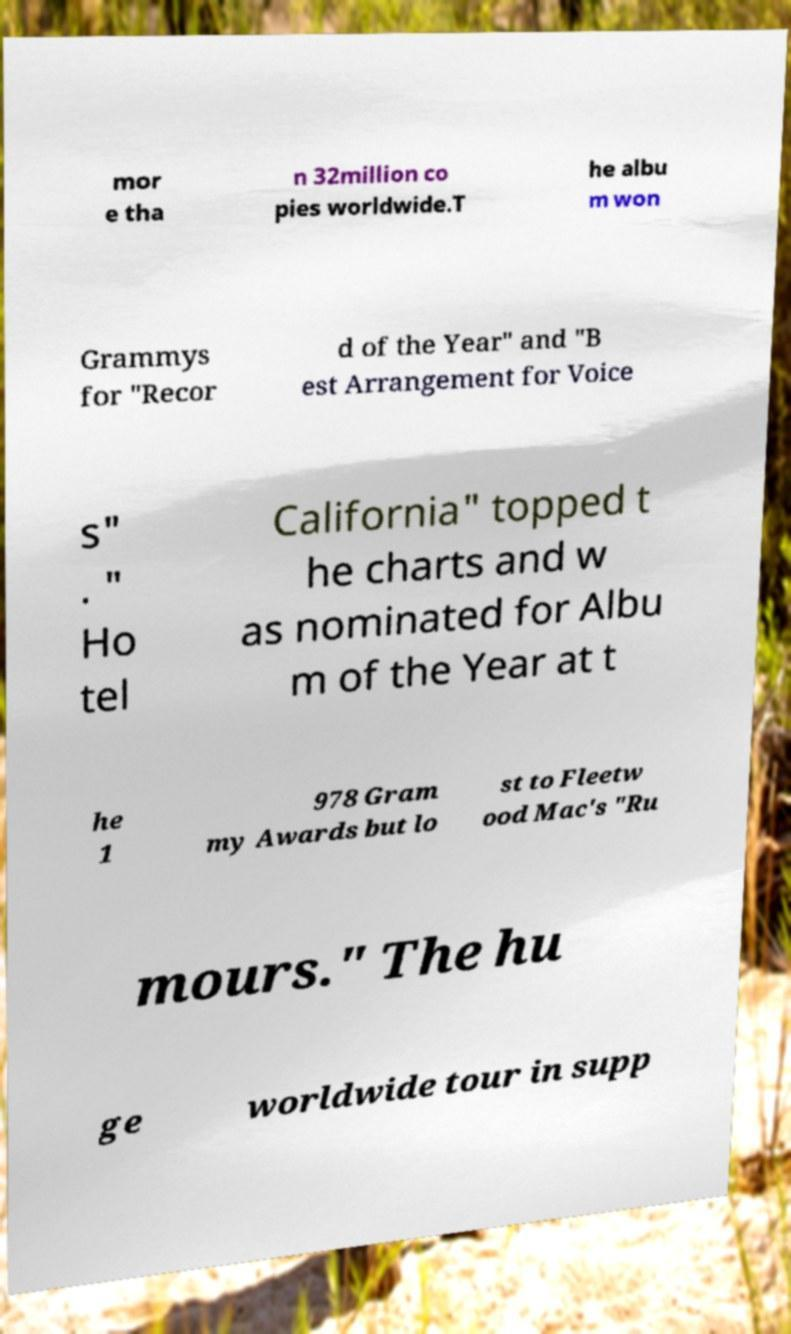What messages or text are displayed in this image? I need them in a readable, typed format. mor e tha n 32million co pies worldwide.T he albu m won Grammys for "Recor d of the Year" and "B est Arrangement for Voice s" . " Ho tel California" topped t he charts and w as nominated for Albu m of the Year at t he 1 978 Gram my Awards but lo st to Fleetw ood Mac's "Ru mours." The hu ge worldwide tour in supp 